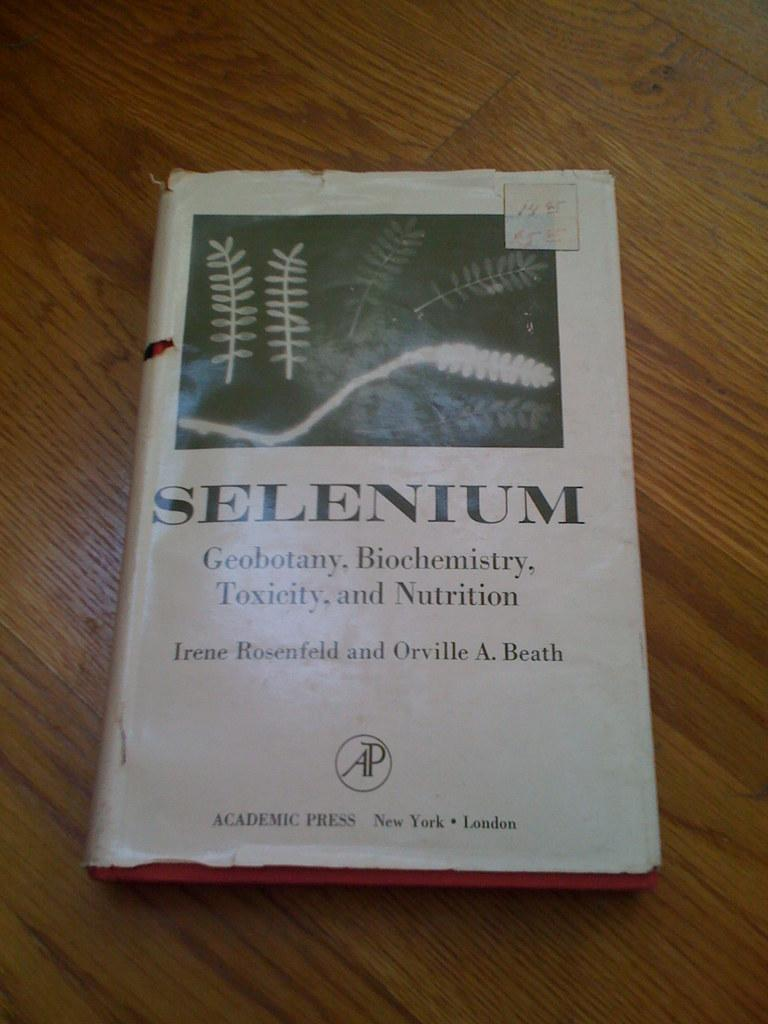Provide a one-sentence caption for the provided image. An old dust jacket covered book entitled Selenium. 